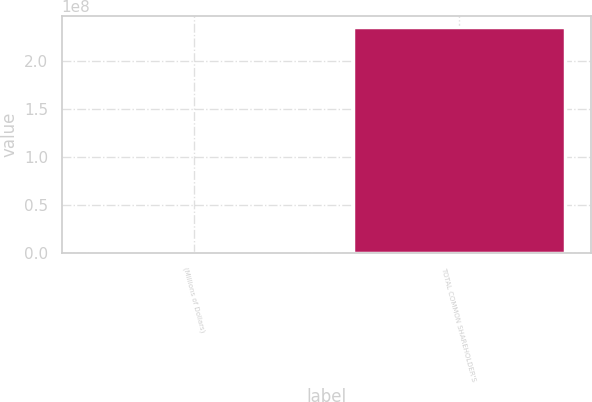Convert chart. <chart><loc_0><loc_0><loc_500><loc_500><bar_chart><fcel>(Millions of Dollars)<fcel>TOTAL COMMON SHAREHOLDER'S<nl><fcel>2014<fcel>2.35488e+08<nl></chart> 